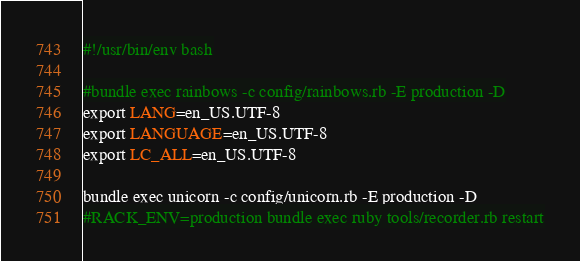<code> <loc_0><loc_0><loc_500><loc_500><_Bash_>#!/usr/bin/env bash

#bundle exec rainbows -c config/rainbows.rb -E production -D
export LANG=en_US.UTF-8
export LANGUAGE=en_US.UTF-8
export LC_ALL=en_US.UTF-8

bundle exec unicorn -c config/unicorn.rb -E production -D
#RACK_ENV=production bundle exec ruby tools/recorder.rb restart</code> 